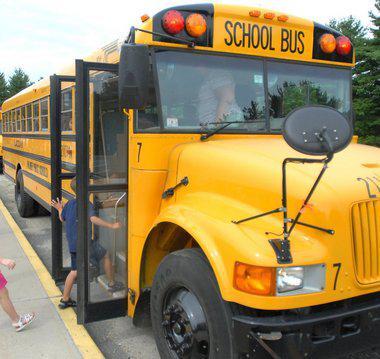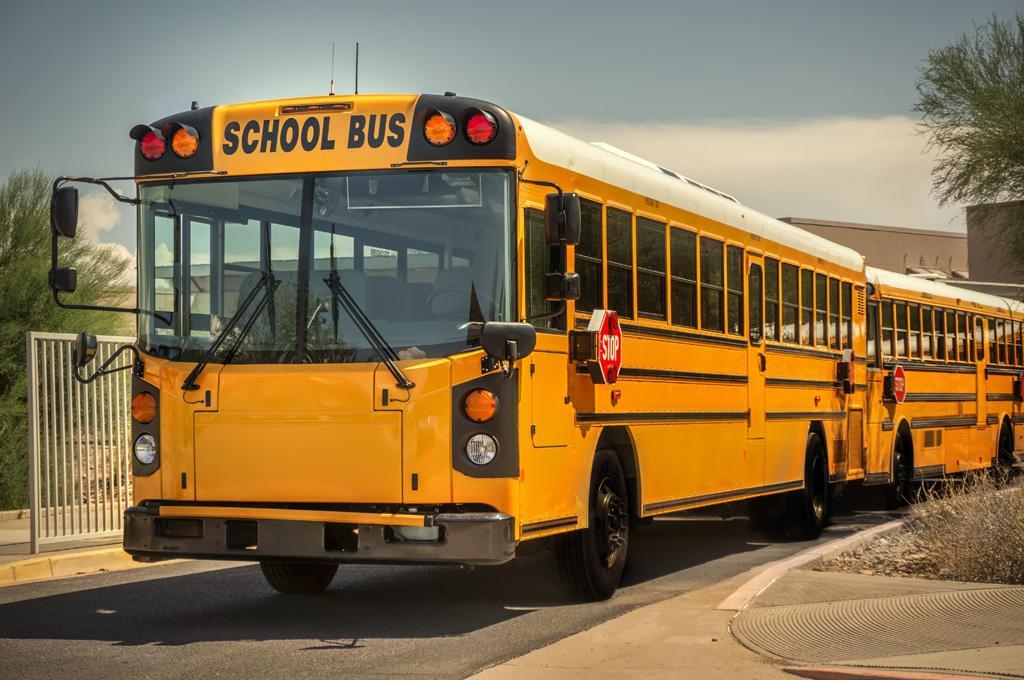The first image is the image on the left, the second image is the image on the right. Analyze the images presented: Is the assertion "A child is entering the open door of a school bus parked at a rightward angle in one image, and the other image shows a leftward angled bus." valid? Answer yes or no. Yes. The first image is the image on the left, the second image is the image on the right. Assess this claim about the two images: "People are getting on the bus.". Correct or not? Answer yes or no. Yes. 